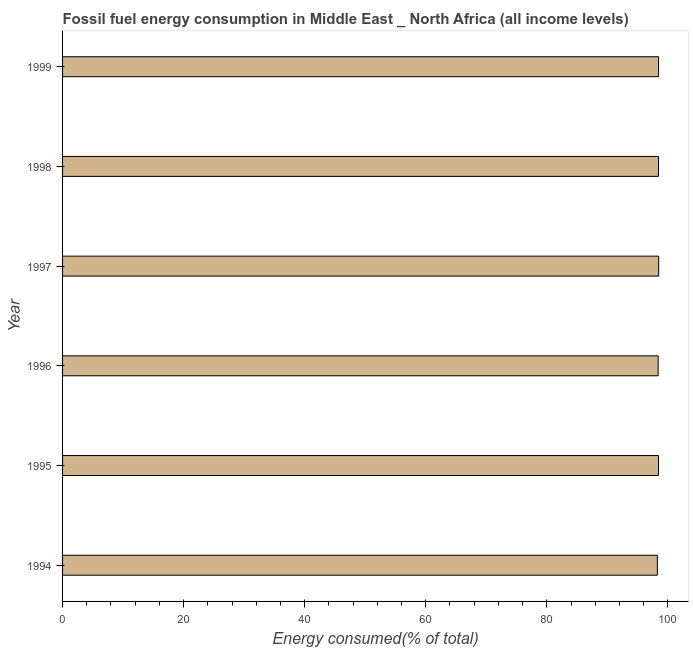Does the graph contain any zero values?
Make the answer very short. No. Does the graph contain grids?
Provide a succinct answer. No. What is the title of the graph?
Your answer should be compact. Fossil fuel energy consumption in Middle East _ North Africa (all income levels). What is the label or title of the X-axis?
Provide a short and direct response. Energy consumed(% of total). What is the fossil fuel energy consumption in 1994?
Offer a very short reply. 98.26. Across all years, what is the maximum fossil fuel energy consumption?
Provide a succinct answer. 98.48. Across all years, what is the minimum fossil fuel energy consumption?
Provide a short and direct response. 98.26. In which year was the fossil fuel energy consumption minimum?
Ensure brevity in your answer.  1994. What is the sum of the fossil fuel energy consumption?
Offer a very short reply. 590.5. What is the difference between the fossil fuel energy consumption in 1996 and 1997?
Your answer should be compact. -0.09. What is the average fossil fuel energy consumption per year?
Make the answer very short. 98.42. What is the median fossil fuel energy consumption?
Give a very brief answer. 98.45. In how many years, is the fossil fuel energy consumption greater than 76 %?
Give a very brief answer. 6. Is the fossil fuel energy consumption in 1995 less than that in 1996?
Ensure brevity in your answer.  No. What is the difference between the highest and the second highest fossil fuel energy consumption?
Give a very brief answer. 0.02. Is the sum of the fossil fuel energy consumption in 1995 and 1998 greater than the maximum fossil fuel energy consumption across all years?
Offer a terse response. Yes. What is the difference between the highest and the lowest fossil fuel energy consumption?
Make the answer very short. 0.22. In how many years, is the fossil fuel energy consumption greater than the average fossil fuel energy consumption taken over all years?
Give a very brief answer. 4. Are all the bars in the graph horizontal?
Provide a succinct answer. Yes. How many years are there in the graph?
Keep it short and to the point. 6. What is the Energy consumed(% of total) of 1994?
Offer a very short reply. 98.26. What is the Energy consumed(% of total) in 1995?
Offer a very short reply. 98.45. What is the Energy consumed(% of total) of 1996?
Ensure brevity in your answer.  98.4. What is the Energy consumed(% of total) in 1997?
Offer a very short reply. 98.48. What is the Energy consumed(% of total) of 1998?
Offer a terse response. 98.45. What is the Energy consumed(% of total) in 1999?
Provide a succinct answer. 98.46. What is the difference between the Energy consumed(% of total) in 1994 and 1995?
Offer a terse response. -0.19. What is the difference between the Energy consumed(% of total) in 1994 and 1996?
Your answer should be very brief. -0.14. What is the difference between the Energy consumed(% of total) in 1994 and 1997?
Give a very brief answer. -0.22. What is the difference between the Energy consumed(% of total) in 1994 and 1998?
Ensure brevity in your answer.  -0.19. What is the difference between the Energy consumed(% of total) in 1994 and 1999?
Your response must be concise. -0.2. What is the difference between the Energy consumed(% of total) in 1995 and 1996?
Offer a very short reply. 0.06. What is the difference between the Energy consumed(% of total) in 1995 and 1997?
Make the answer very short. -0.03. What is the difference between the Energy consumed(% of total) in 1995 and 1998?
Provide a short and direct response. 0. What is the difference between the Energy consumed(% of total) in 1995 and 1999?
Offer a terse response. -0.01. What is the difference between the Energy consumed(% of total) in 1996 and 1997?
Your answer should be compact. -0.09. What is the difference between the Energy consumed(% of total) in 1996 and 1998?
Your response must be concise. -0.05. What is the difference between the Energy consumed(% of total) in 1996 and 1999?
Keep it short and to the point. -0.07. What is the difference between the Energy consumed(% of total) in 1997 and 1998?
Give a very brief answer. 0.03. What is the difference between the Energy consumed(% of total) in 1997 and 1999?
Offer a terse response. 0.02. What is the difference between the Energy consumed(% of total) in 1998 and 1999?
Your answer should be compact. -0.01. What is the ratio of the Energy consumed(% of total) in 1994 to that in 1996?
Provide a short and direct response. 1. What is the ratio of the Energy consumed(% of total) in 1994 to that in 1999?
Give a very brief answer. 1. What is the ratio of the Energy consumed(% of total) in 1995 to that in 1998?
Give a very brief answer. 1. What is the ratio of the Energy consumed(% of total) in 1995 to that in 1999?
Your response must be concise. 1. What is the ratio of the Energy consumed(% of total) in 1996 to that in 1997?
Provide a succinct answer. 1. What is the ratio of the Energy consumed(% of total) in 1996 to that in 1999?
Offer a very short reply. 1. 